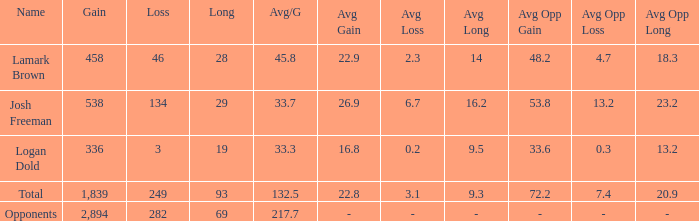Which avg/g is associated with josh freeman and has a loss under 134? None. 